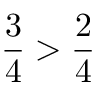<formula> <loc_0><loc_0><loc_500><loc_500>{ \frac { 3 } { 4 } } > { \frac { 2 } { 4 } }</formula> 